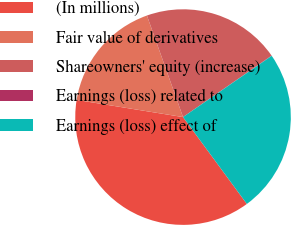<chart> <loc_0><loc_0><loc_500><loc_500><pie_chart><fcel>(In millions)<fcel>Fair value of derivatives<fcel>Shareowners' equity (increase)<fcel>Earnings (loss) related to<fcel>Earnings (loss) effect of<nl><fcel>37.64%<fcel>17.02%<fcel>20.78%<fcel>0.04%<fcel>24.54%<nl></chart> 